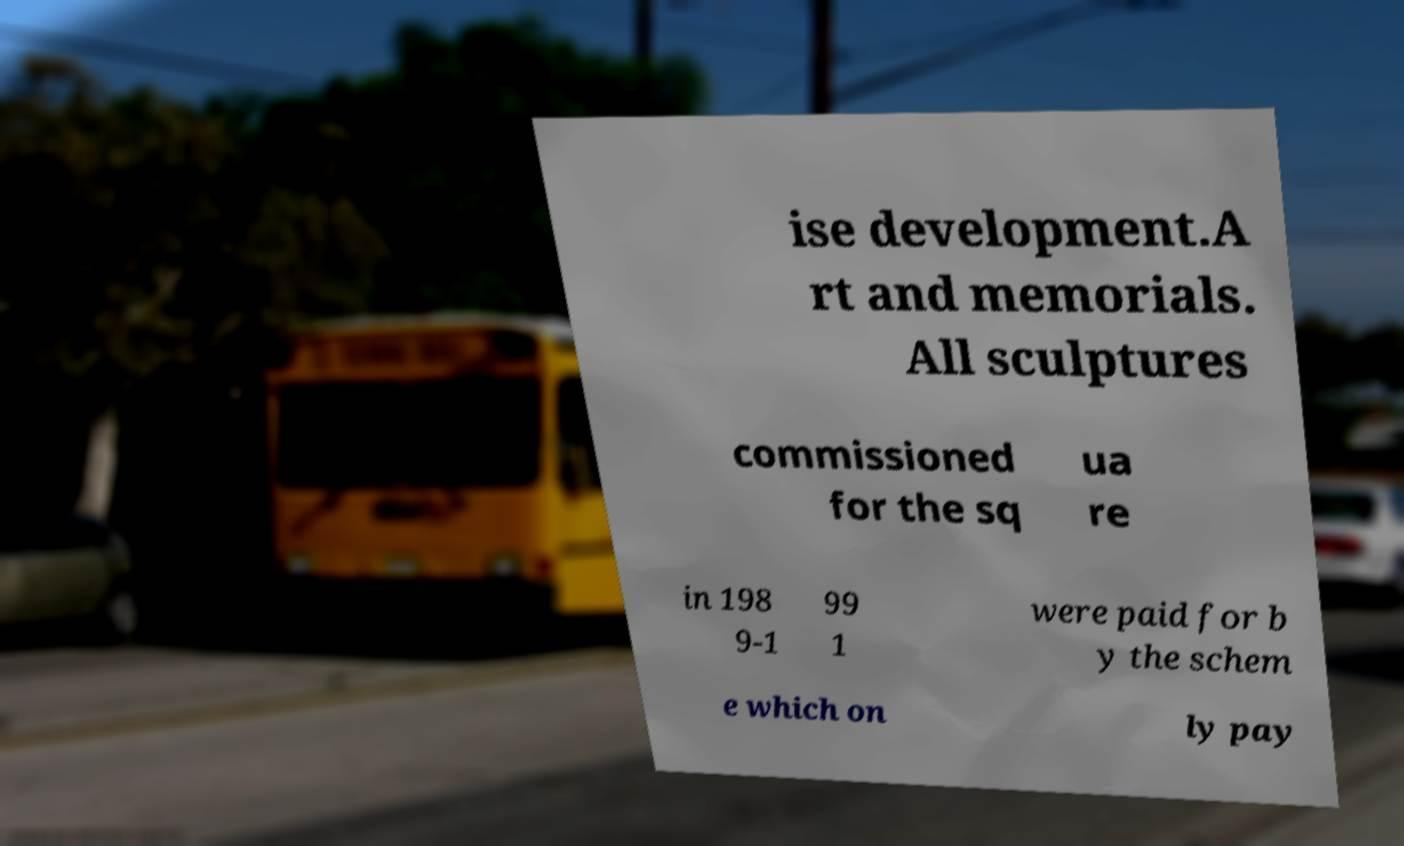Could you extract and type out the text from this image? ise development.A rt and memorials. All sculptures commissioned for the sq ua re in 198 9-1 99 1 were paid for b y the schem e which on ly pay 